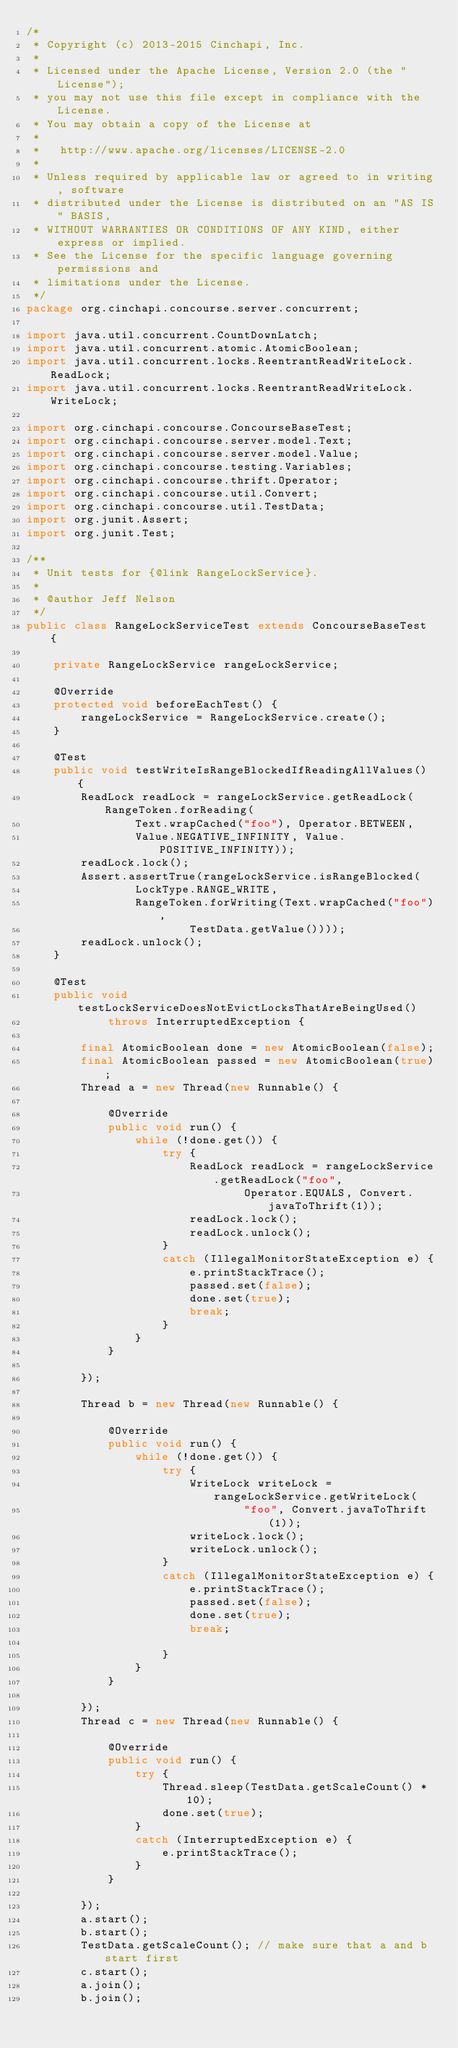<code> <loc_0><loc_0><loc_500><loc_500><_Java_>/*
 * Copyright (c) 2013-2015 Cinchapi, Inc.
 *
 * Licensed under the Apache License, Version 2.0 (the "License");
 * you may not use this file except in compliance with the License.
 * You may obtain a copy of the License at
 *
 *   http://www.apache.org/licenses/LICENSE-2.0
 *
 * Unless required by applicable law or agreed to in writing, software
 * distributed under the License is distributed on an "AS IS" BASIS,
 * WITHOUT WARRANTIES OR CONDITIONS OF ANY KIND, either express or implied.
 * See the License for the specific language governing permissions and
 * limitations under the License.
 */
package org.cinchapi.concourse.server.concurrent;

import java.util.concurrent.CountDownLatch;
import java.util.concurrent.atomic.AtomicBoolean;
import java.util.concurrent.locks.ReentrantReadWriteLock.ReadLock;
import java.util.concurrent.locks.ReentrantReadWriteLock.WriteLock;

import org.cinchapi.concourse.ConcourseBaseTest;
import org.cinchapi.concourse.server.model.Text;
import org.cinchapi.concourse.server.model.Value;
import org.cinchapi.concourse.testing.Variables;
import org.cinchapi.concourse.thrift.Operator;
import org.cinchapi.concourse.util.Convert;
import org.cinchapi.concourse.util.TestData;
import org.junit.Assert;
import org.junit.Test;

/**
 * Unit tests for {@link RangeLockService}.
 * 
 * @author Jeff Nelson
 */
public class RangeLockServiceTest extends ConcourseBaseTest {

    private RangeLockService rangeLockService;

    @Override
    protected void beforeEachTest() {
        rangeLockService = RangeLockService.create();
    }

    @Test
    public void testWriteIsRangeBlockedIfReadingAllValues() {
        ReadLock readLock = rangeLockService.getReadLock(RangeToken.forReading(
                Text.wrapCached("foo"), Operator.BETWEEN,
                Value.NEGATIVE_INFINITY, Value.POSITIVE_INFINITY));
        readLock.lock();
        Assert.assertTrue(rangeLockService.isRangeBlocked(
                LockType.RANGE_WRITE,
                RangeToken.forWriting(Text.wrapCached("foo"),
                        TestData.getValue())));
        readLock.unlock();
    }

    @Test
    public void testLockServiceDoesNotEvictLocksThatAreBeingUsed()
            throws InterruptedException {

        final AtomicBoolean done = new AtomicBoolean(false);
        final AtomicBoolean passed = new AtomicBoolean(true);
        Thread a = new Thread(new Runnable() {

            @Override
            public void run() {
                while (!done.get()) {
                    try {
                        ReadLock readLock = rangeLockService.getReadLock("foo",
                                Operator.EQUALS, Convert.javaToThrift(1));
                        readLock.lock();
                        readLock.unlock();
                    }
                    catch (IllegalMonitorStateException e) {
                        e.printStackTrace();
                        passed.set(false);
                        done.set(true);
                        break;
                    }
                }
            }

        });

        Thread b = new Thread(new Runnable() {

            @Override
            public void run() {
                while (!done.get()) {
                    try {
                        WriteLock writeLock = rangeLockService.getWriteLock(
                                "foo", Convert.javaToThrift(1));
                        writeLock.lock();
                        writeLock.unlock();
                    }
                    catch (IllegalMonitorStateException e) {
                        e.printStackTrace();
                        passed.set(false);
                        done.set(true);
                        break;

                    }
                }
            }

        });
        Thread c = new Thread(new Runnable() {

            @Override
            public void run() {
                try {
                    Thread.sleep(TestData.getScaleCount() * 10);
                    done.set(true);
                }
                catch (InterruptedException e) {
                    e.printStackTrace();
                }
            }

        });
        a.start();
        b.start();
        TestData.getScaleCount(); // make sure that a and b start first
        c.start();
        a.join();
        b.join();</code> 